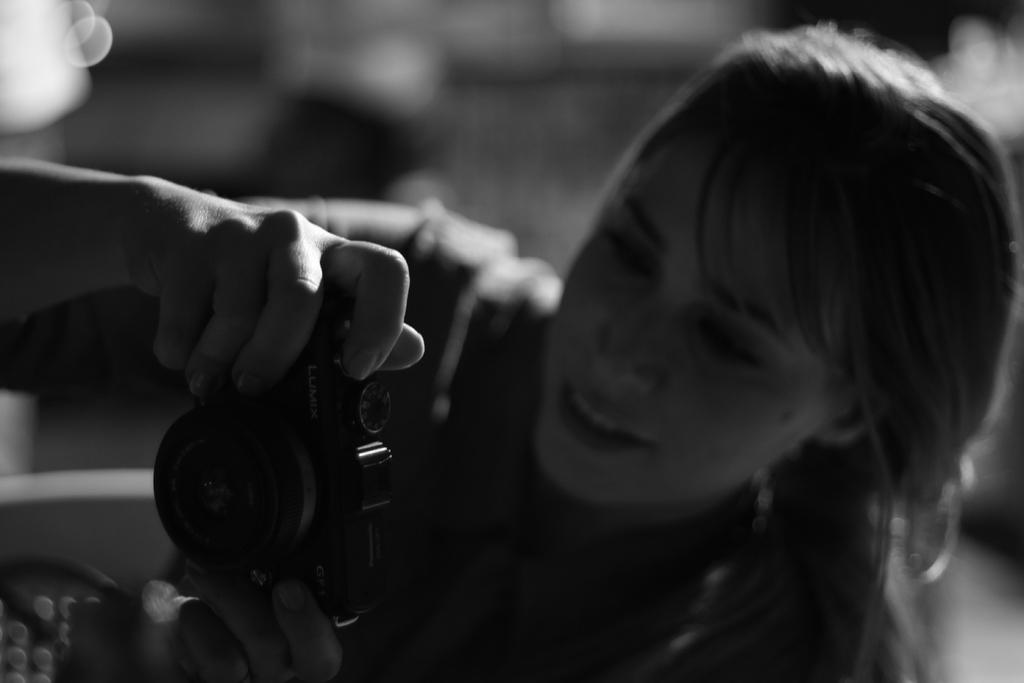What is the color scheme of the picture? The picture is black and white. Who or what is the main subject in the image? There is a woman in the picture. What is the woman holding in the image? The woman is holding a camera. What type of animal can be seen playing the drum in the image? There is no animal or drum present in the image; it features a woman holding a camera. 